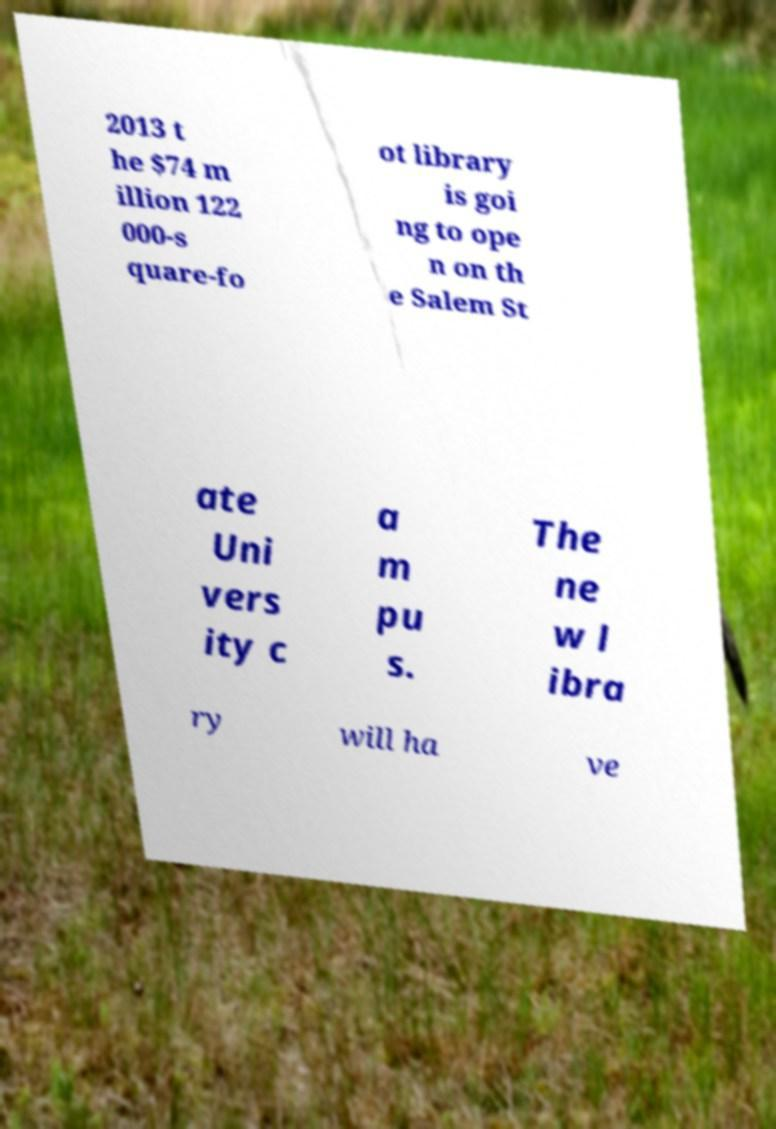I need the written content from this picture converted into text. Can you do that? 2013 t he $74 m illion 122 000-s quare-fo ot library is goi ng to ope n on th e Salem St ate Uni vers ity c a m pu s. The ne w l ibra ry will ha ve 